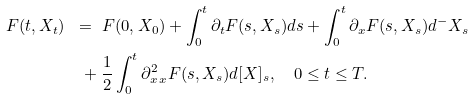Convert formula to latex. <formula><loc_0><loc_0><loc_500><loc_500>F ( t , X _ { t } ) \ & = \ F ( 0 , X _ { 0 } ) + \int _ { 0 } ^ { t } \partial _ { t } F ( s , X _ { s } ) d s + \int _ { 0 } ^ { t } \partial _ { x } F ( s , X _ { s } ) d ^ { - } X _ { s } \\ & \ + \frac { 1 } { 2 } \int _ { 0 } ^ { t } \partial ^ { 2 } _ { x \, x } F ( s , X _ { s } ) d [ X ] _ { s } , \quad 0 \leq t \leq T .</formula> 